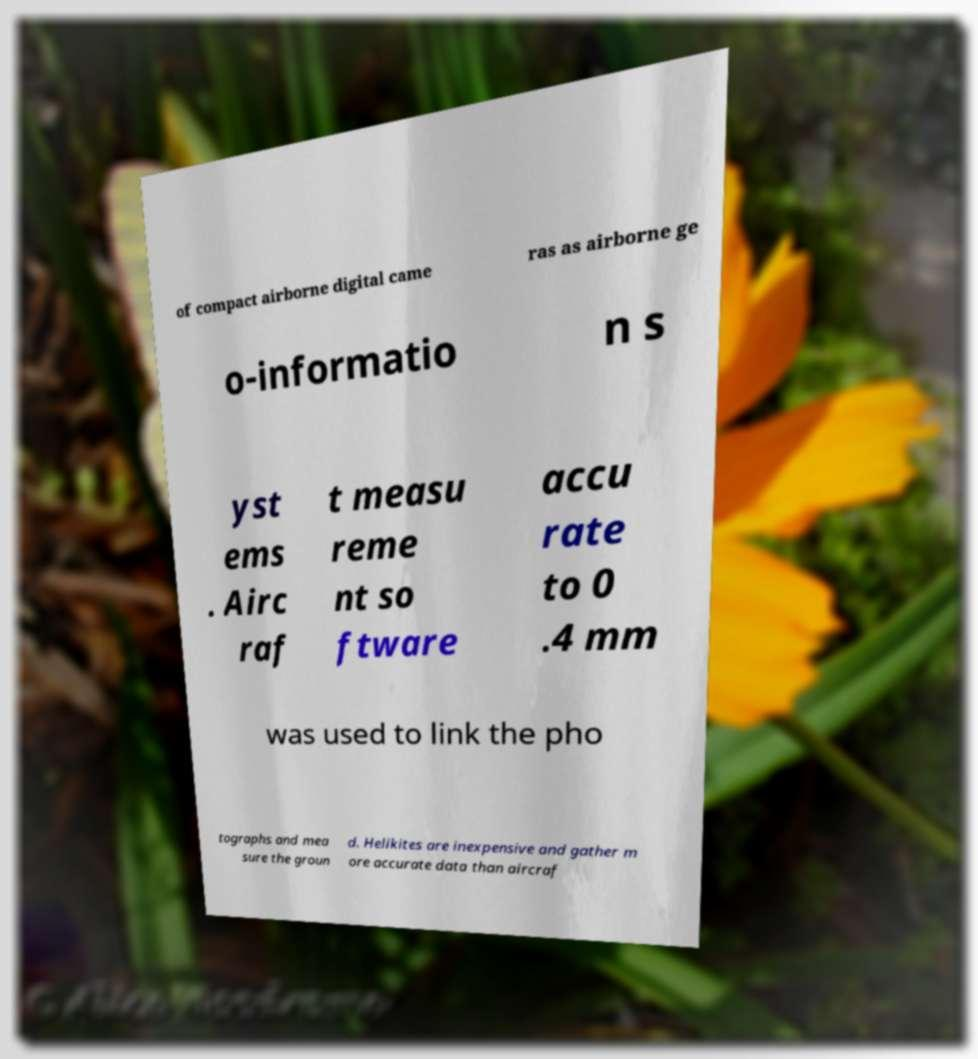There's text embedded in this image that I need extracted. Can you transcribe it verbatim? of compact airborne digital came ras as airborne ge o-informatio n s yst ems . Airc raf t measu reme nt so ftware accu rate to 0 .4 mm was used to link the pho tographs and mea sure the groun d. Helikites are inexpensive and gather m ore accurate data than aircraf 